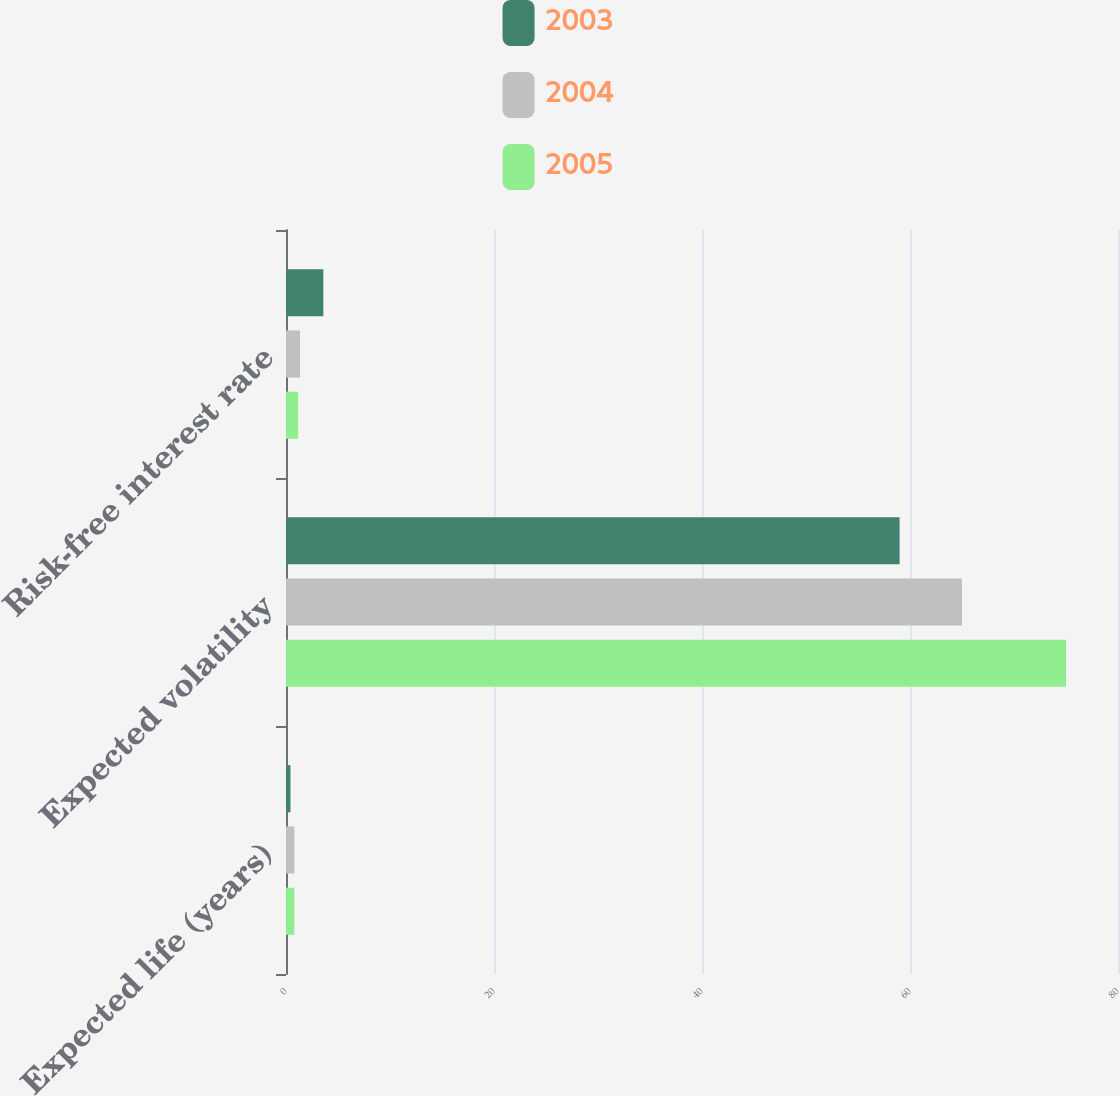<chart> <loc_0><loc_0><loc_500><loc_500><stacked_bar_chart><ecel><fcel>Expected life (years)<fcel>Expected volatility<fcel>Risk-free interest rate<nl><fcel>2003<fcel>0.43<fcel>59<fcel>3.59<nl><fcel>2004<fcel>0.8<fcel>65<fcel>1.35<nl><fcel>2005<fcel>0.8<fcel>75<fcel>1.17<nl></chart> 